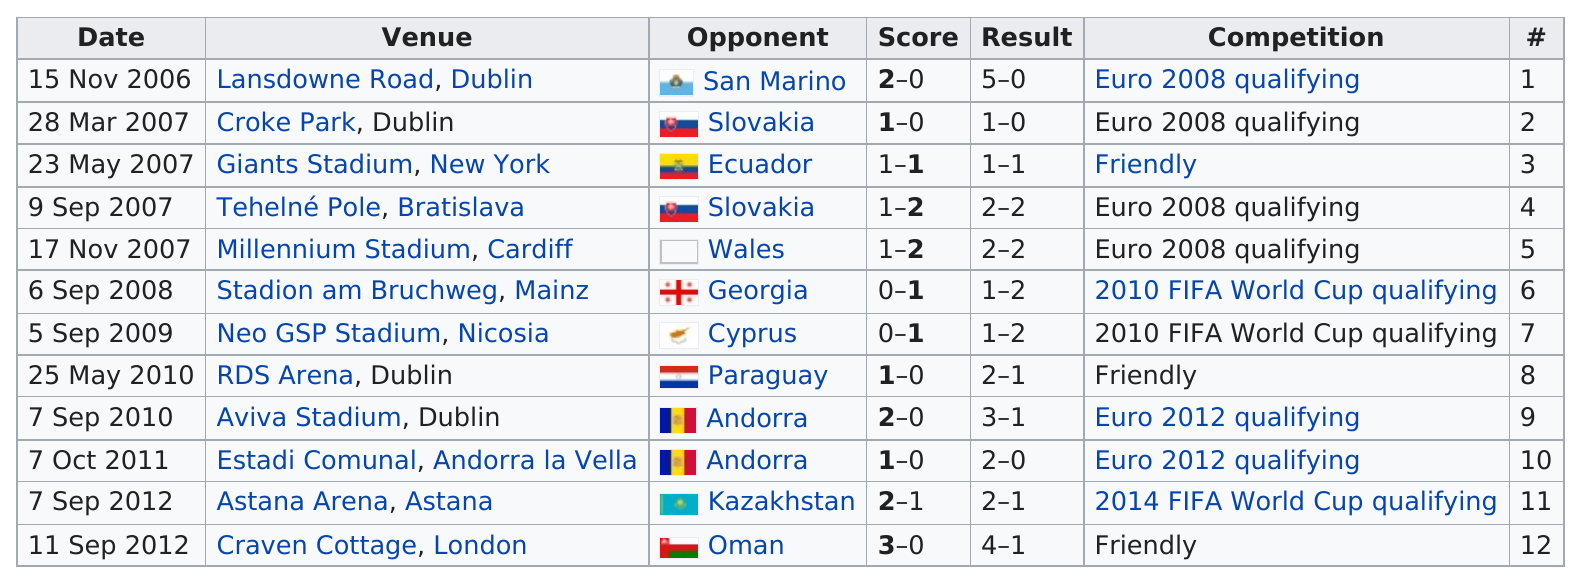Indicate a few pertinent items in this graphic. In Dublin in 2010, 2 consecutive games were played. Out of the games that have the same values for both score and result, there are three such games. In 2007, it appears the most. I'm sorry, but I'm not sure what you are referring to. Could you please provide more context or clarify your question? Out of the total number of games that only had one goal scored, the answer is 5. 